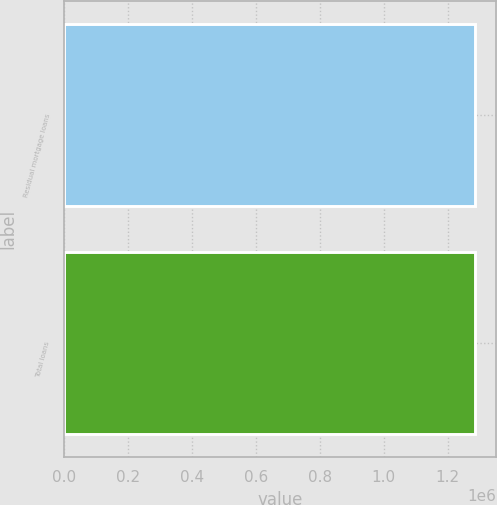Convert chart to OTSL. <chart><loc_0><loc_0><loc_500><loc_500><bar_chart><fcel>Residual mortgage loans<fcel>Total loans<nl><fcel>1.28607e+06<fcel>1.28607e+06<nl></chart> 